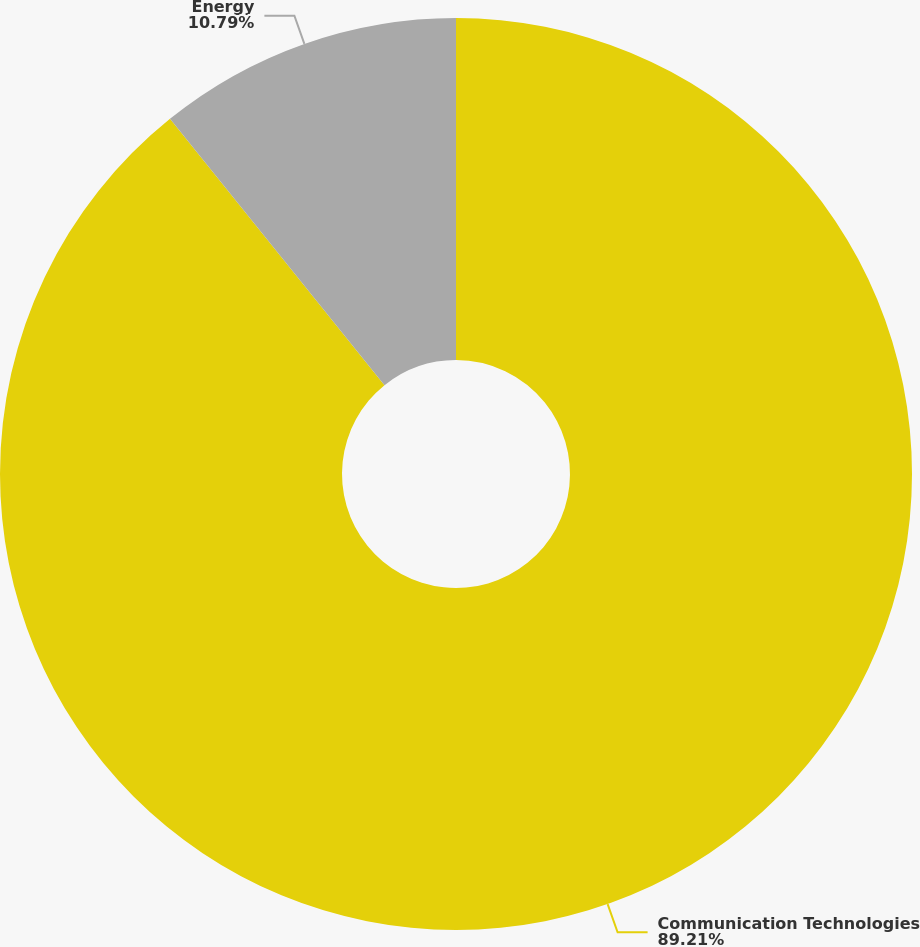<chart> <loc_0><loc_0><loc_500><loc_500><pie_chart><fcel>Communication Technologies<fcel>Energy<nl><fcel>89.21%<fcel>10.79%<nl></chart> 